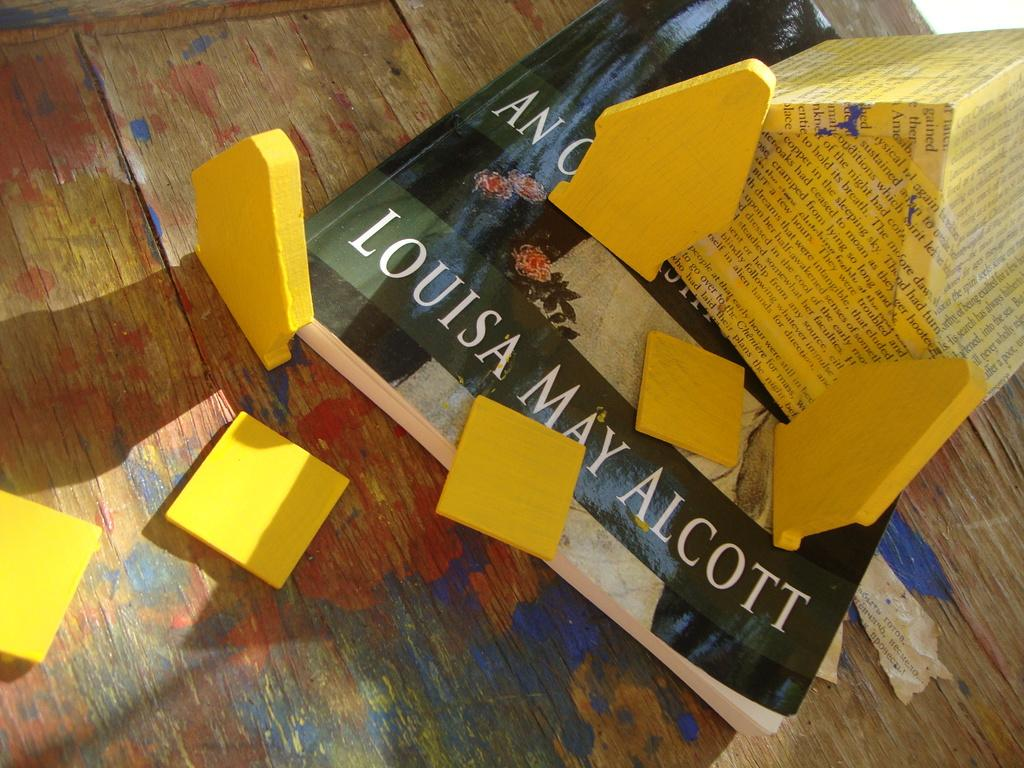<image>
Render a clear and concise summary of the photo. Some yellow wooden blocks sit on top of a book by Louisa May Alcott. 